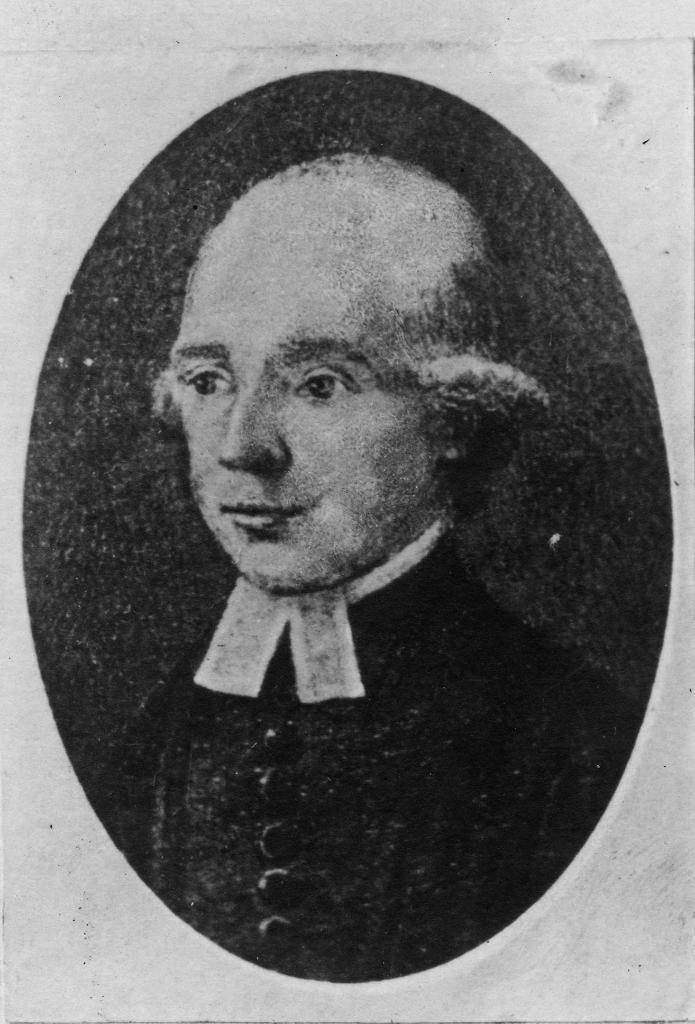What is the color scheme of the image? The image is black and white. What can be seen in the image? There is a photo of a person in the image. What type of apparatus is being used to apply a shock to the person in the image? There is no apparatus or shock present in the image; it only features a photo of a person. 